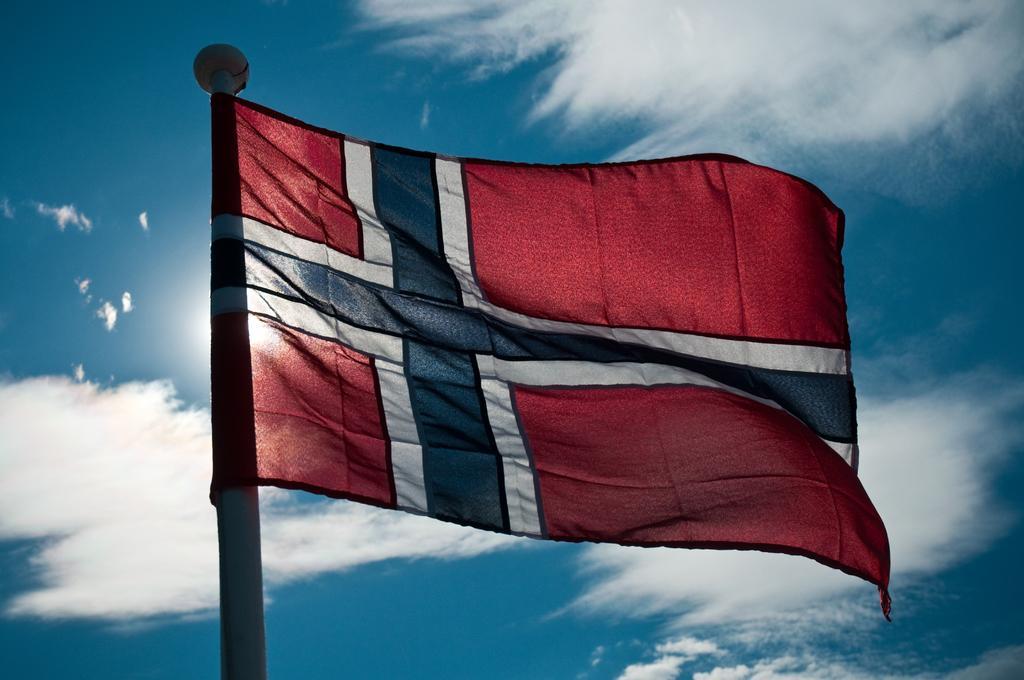Describe this image in one or two sentences. This image is taken outdoors. In the background there is a sky with clouds. In the middle of the image there is a flag and a flagpole. 